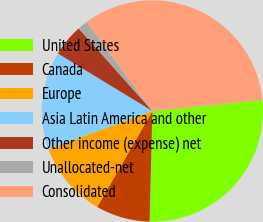<chart> <loc_0><loc_0><loc_500><loc_500><pie_chart><fcel>United States<fcel>Canada<fcel>Europe<fcel>Asia Latin America and other<fcel>Other income (expense) net<fcel>Unallocated-net<fcel>Consolidated<nl><fcel>26.99%<fcel>7.9%<fcel>11.1%<fcel>14.3%<fcel>4.7%<fcel>1.5%<fcel>33.51%<nl></chart> 